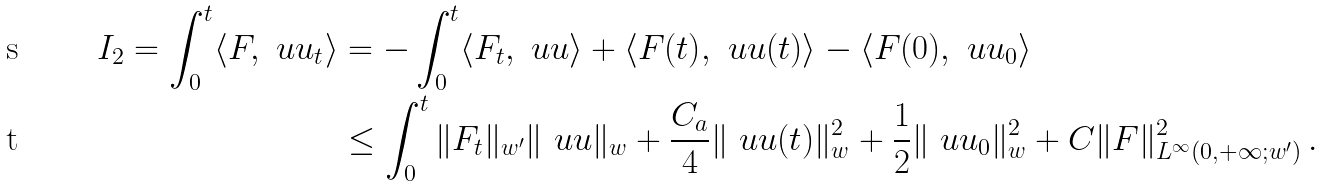Convert formula to latex. <formula><loc_0><loc_0><loc_500><loc_500>I _ { 2 } = \int _ { 0 } ^ { t } \langle F , \ u u _ { t } \rangle & = - \int _ { 0 } ^ { t } \langle F _ { t } , \ u u \rangle + \langle F ( t ) , \ u u ( t ) \rangle - \langle F ( 0 ) , \ u u _ { 0 } \rangle \\ & \leq \int _ { 0 } ^ { t } \| F _ { t } \| _ { w ^ { \prime } } \| \ u u \| _ { w } + \frac { C _ { a } } { 4 } \| \ u u ( t ) \| _ { w } ^ { 2 } + \frac { 1 } { 2 } \| \ u u _ { 0 } \| _ { w } ^ { 2 } + C \| F \| _ { L ^ { \infty } ( 0 , + \infty ; w ^ { \prime } ) } ^ { 2 } \, .</formula> 